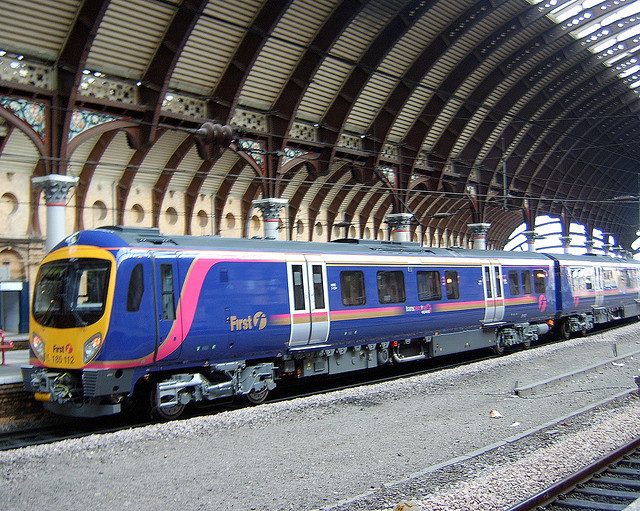Please extract the text content from this image. First First 125 112 